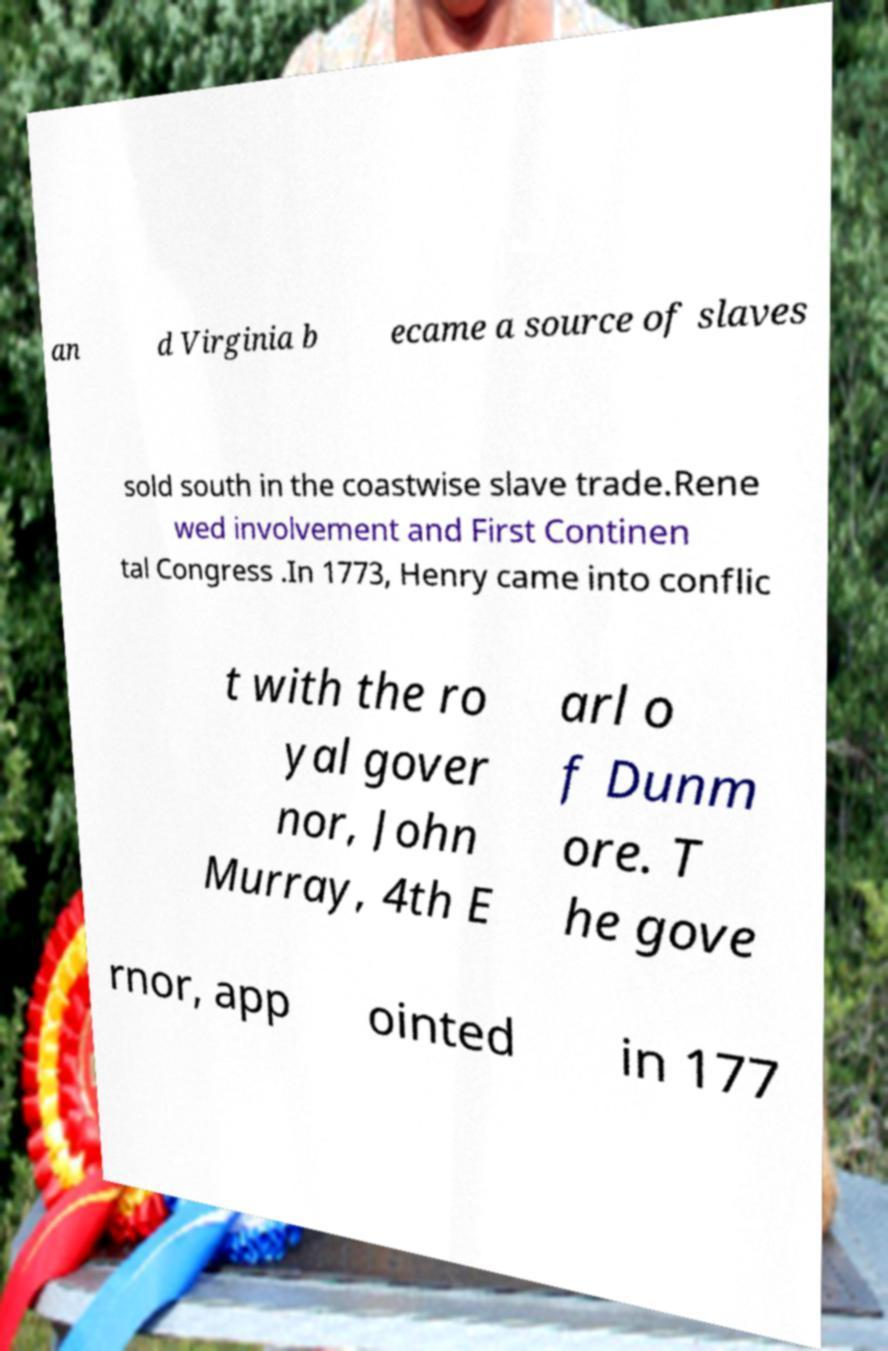Could you extract and type out the text from this image? an d Virginia b ecame a source of slaves sold south in the coastwise slave trade.Rene wed involvement and First Continen tal Congress .In 1773, Henry came into conflic t with the ro yal gover nor, John Murray, 4th E arl o f Dunm ore. T he gove rnor, app ointed in 177 